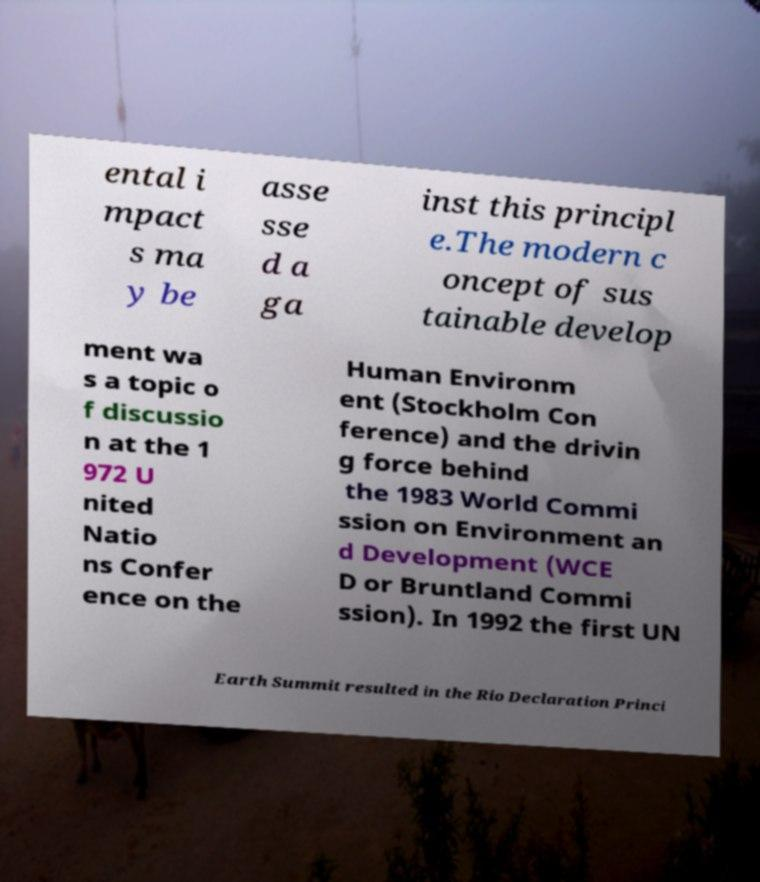Please read and relay the text visible in this image. What does it say? ental i mpact s ma y be asse sse d a ga inst this principl e.The modern c oncept of sus tainable develop ment wa s a topic o f discussio n at the 1 972 U nited Natio ns Confer ence on the Human Environm ent (Stockholm Con ference) and the drivin g force behind the 1983 World Commi ssion on Environment an d Development (WCE D or Bruntland Commi ssion). In 1992 the first UN Earth Summit resulted in the Rio Declaration Princi 